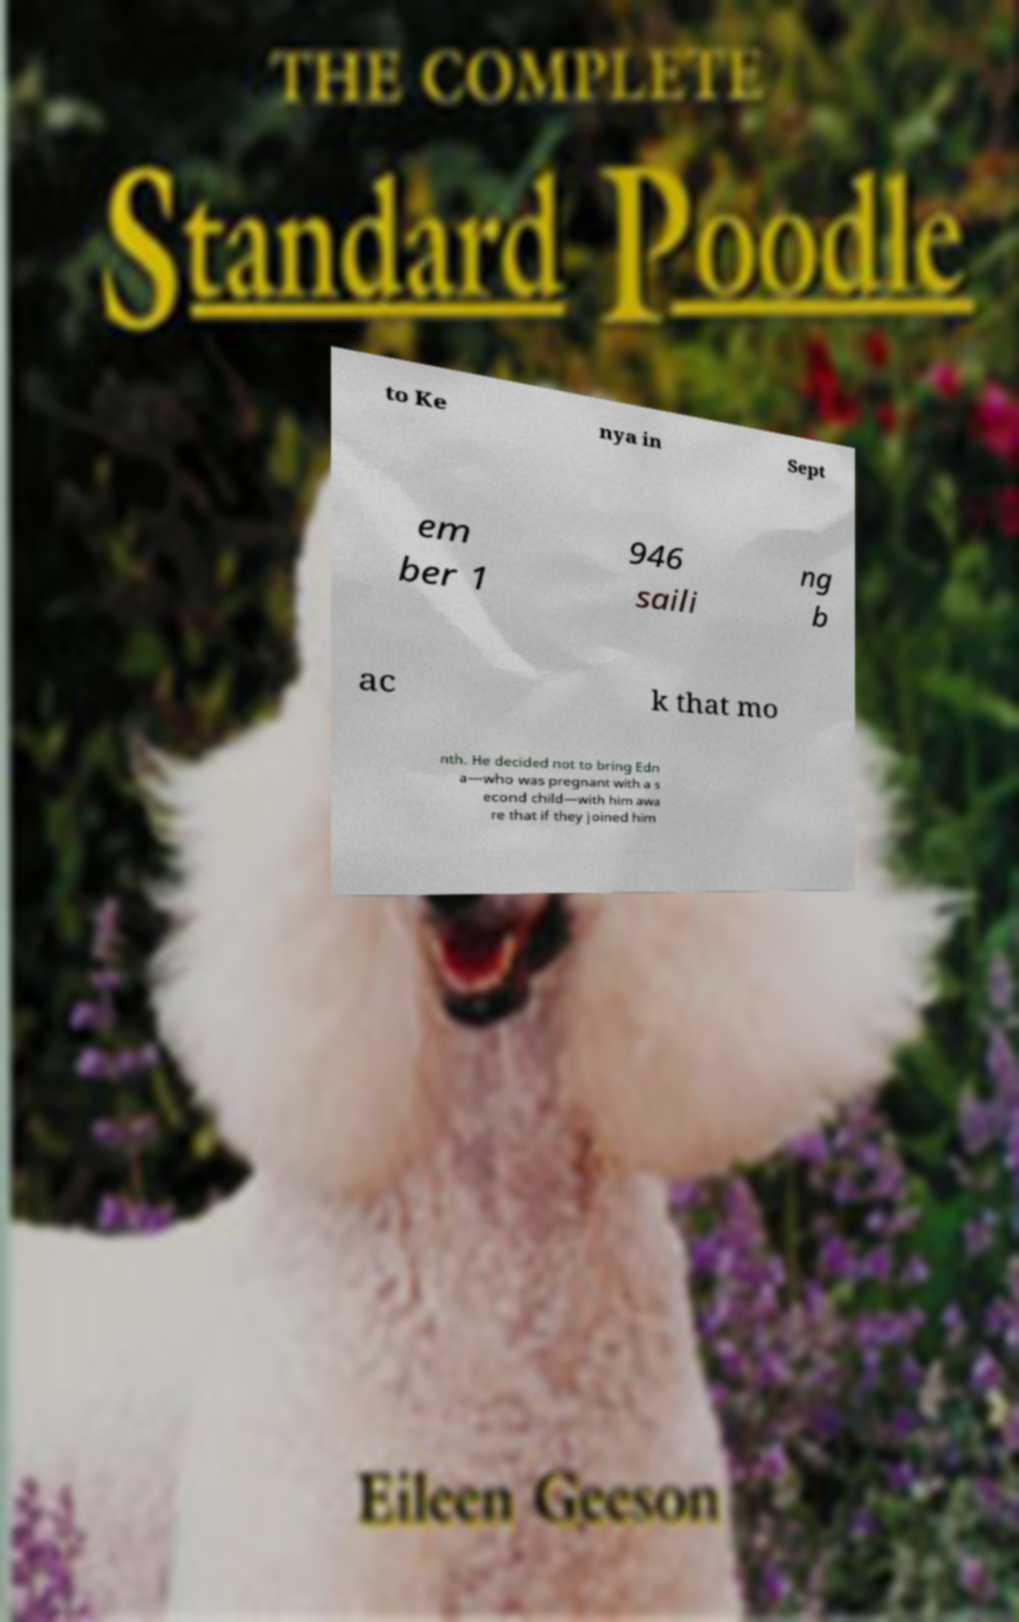For documentation purposes, I need the text within this image transcribed. Could you provide that? to Ke nya in Sept em ber 1 946 saili ng b ac k that mo nth. He decided not to bring Edn a—who was pregnant with a s econd child—with him awa re that if they joined him 